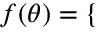<formula> <loc_0><loc_0><loc_500><loc_500>\begin{array} { r } { f ( \theta ) = \left \{ \begin{array} { l l } \end{array} } \end{array}</formula> 